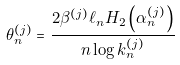Convert formula to latex. <formula><loc_0><loc_0><loc_500><loc_500>\theta _ { n } ^ { ( j ) } = \frac { 2 \beta ^ { ( j ) } \ell _ { n } H _ { 2 } \left ( \alpha _ { n } ^ { ( j ) } \right ) } { n \log k _ { n } ^ { ( j ) } }</formula> 